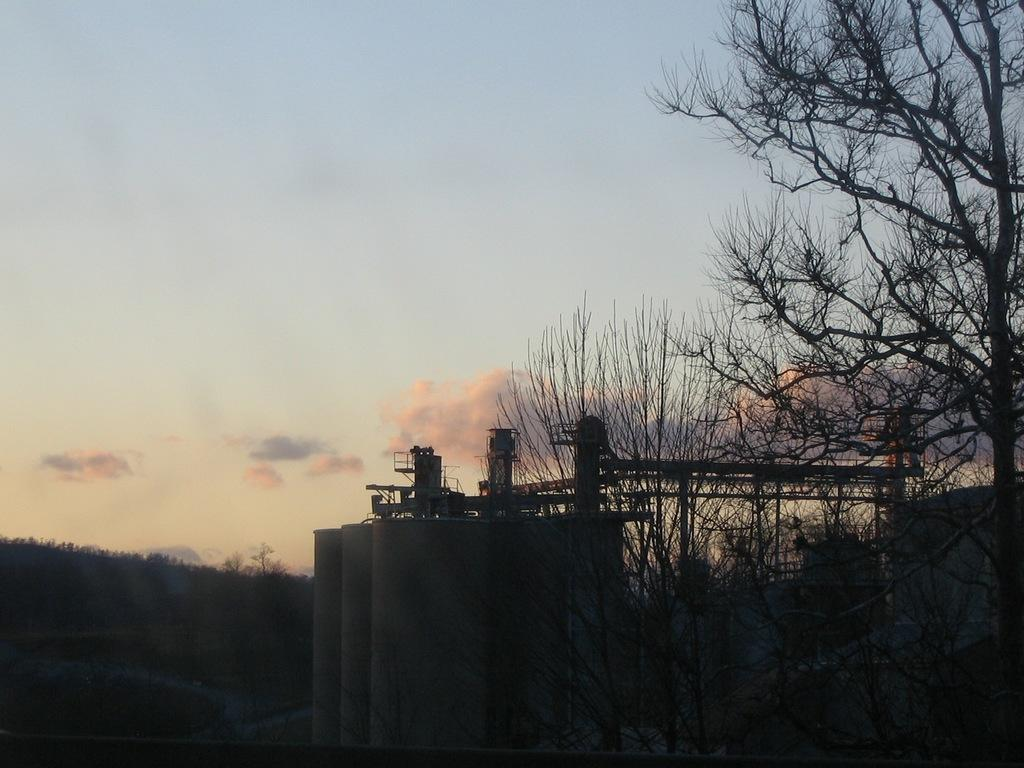What type of structure is the main subject in the image? There is a factory in the image. Are there any natural elements present near the factory? Yes, there are trees beside the factory. What can be seen in the background of the image? The sky is visible in the background of the image. What is the condition of the sky in the image? Clouds are present in the sky. How many pizzas are being delivered to the factory in the image? There is no mention of pizzas or delivery in the image; it features a factory with trees and a cloudy sky. 